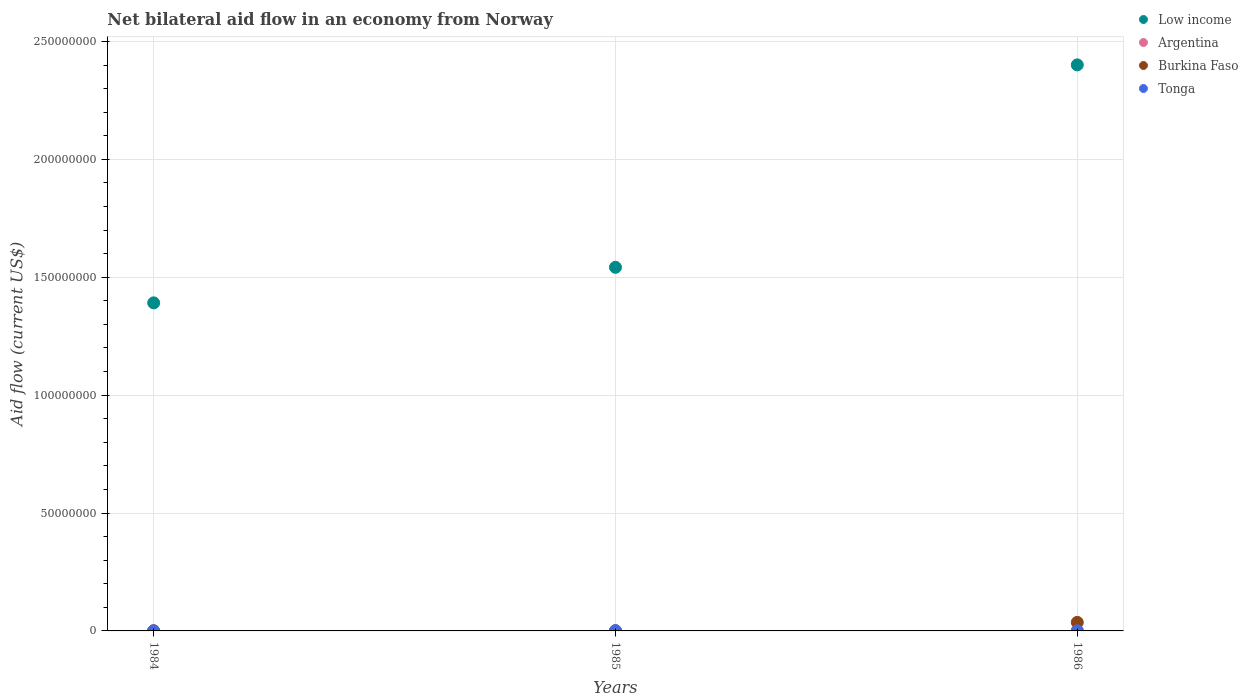What is the net bilateral aid flow in Burkina Faso in 1985?
Offer a terse response. 2.00e+04. Across all years, what is the maximum net bilateral aid flow in Argentina?
Make the answer very short. 1.70e+05. In which year was the net bilateral aid flow in Tonga maximum?
Your answer should be compact. 1985. What is the total net bilateral aid flow in Low income in the graph?
Make the answer very short. 5.33e+08. What is the difference between the net bilateral aid flow in Burkina Faso in 1984 and that in 1986?
Offer a very short reply. -3.59e+06. What is the difference between the net bilateral aid flow in Burkina Faso in 1984 and the net bilateral aid flow in Argentina in 1986?
Offer a terse response. -1.30e+05. What is the average net bilateral aid flow in Burkina Faso per year?
Make the answer very short. 1.23e+06. In the year 1984, what is the difference between the net bilateral aid flow in Low income and net bilateral aid flow in Tonga?
Provide a succinct answer. 1.39e+08. In how many years, is the net bilateral aid flow in Low income greater than 20000000 US$?
Make the answer very short. 3. Is the net bilateral aid flow in Low income in 1985 less than that in 1986?
Provide a succinct answer. Yes. Is the difference between the net bilateral aid flow in Low income in 1984 and 1985 greater than the difference between the net bilateral aid flow in Tonga in 1984 and 1985?
Your response must be concise. No. What is the difference between the highest and the second highest net bilateral aid flow in Burkina Faso?
Offer a terse response. 3.59e+06. What is the difference between the highest and the lowest net bilateral aid flow in Low income?
Give a very brief answer. 1.01e+08. In how many years, is the net bilateral aid flow in Argentina greater than the average net bilateral aid flow in Argentina taken over all years?
Keep it short and to the point. 1. Is the sum of the net bilateral aid flow in Low income in 1984 and 1986 greater than the maximum net bilateral aid flow in Tonga across all years?
Make the answer very short. Yes. Is it the case that in every year, the sum of the net bilateral aid flow in Low income and net bilateral aid flow in Tonga  is greater than the net bilateral aid flow in Burkina Faso?
Offer a very short reply. Yes. Does the net bilateral aid flow in Tonga monotonically increase over the years?
Offer a terse response. No. Is the net bilateral aid flow in Low income strictly greater than the net bilateral aid flow in Tonga over the years?
Give a very brief answer. Yes. How many dotlines are there?
Provide a short and direct response. 4. How many years are there in the graph?
Keep it short and to the point. 3. What is the difference between two consecutive major ticks on the Y-axis?
Provide a short and direct response. 5.00e+07. Are the values on the major ticks of Y-axis written in scientific E-notation?
Give a very brief answer. No. Does the graph contain grids?
Keep it short and to the point. Yes. Where does the legend appear in the graph?
Provide a succinct answer. Top right. How many legend labels are there?
Make the answer very short. 4. What is the title of the graph?
Offer a terse response. Net bilateral aid flow in an economy from Norway. Does "Middle East & North Africa (developing only)" appear as one of the legend labels in the graph?
Your answer should be compact. No. What is the label or title of the X-axis?
Offer a terse response. Years. What is the label or title of the Y-axis?
Offer a terse response. Aid flow (current US$). What is the Aid flow (current US$) in Low income in 1984?
Your answer should be very brief. 1.39e+08. What is the Aid flow (current US$) of Argentina in 1984?
Provide a short and direct response. 2.00e+04. What is the Aid flow (current US$) in Burkina Faso in 1984?
Give a very brief answer. 4.00e+04. What is the Aid flow (current US$) in Tonga in 1984?
Your answer should be very brief. 2.00e+04. What is the Aid flow (current US$) in Low income in 1985?
Provide a short and direct response. 1.54e+08. What is the Aid flow (current US$) in Burkina Faso in 1985?
Keep it short and to the point. 2.00e+04. What is the Aid flow (current US$) in Low income in 1986?
Offer a terse response. 2.40e+08. What is the Aid flow (current US$) in Argentina in 1986?
Provide a succinct answer. 1.70e+05. What is the Aid flow (current US$) of Burkina Faso in 1986?
Offer a terse response. 3.63e+06. Across all years, what is the maximum Aid flow (current US$) of Low income?
Make the answer very short. 2.40e+08. Across all years, what is the maximum Aid flow (current US$) of Burkina Faso?
Ensure brevity in your answer.  3.63e+06. Across all years, what is the maximum Aid flow (current US$) of Tonga?
Ensure brevity in your answer.  1.00e+05. Across all years, what is the minimum Aid flow (current US$) of Low income?
Keep it short and to the point. 1.39e+08. Across all years, what is the minimum Aid flow (current US$) of Burkina Faso?
Make the answer very short. 2.00e+04. What is the total Aid flow (current US$) of Low income in the graph?
Your response must be concise. 5.33e+08. What is the total Aid flow (current US$) in Argentina in the graph?
Your answer should be very brief. 2.40e+05. What is the total Aid flow (current US$) of Burkina Faso in the graph?
Your answer should be compact. 3.69e+06. What is the total Aid flow (current US$) in Tonga in the graph?
Make the answer very short. 1.70e+05. What is the difference between the Aid flow (current US$) in Low income in 1984 and that in 1985?
Give a very brief answer. -1.51e+07. What is the difference between the Aid flow (current US$) in Low income in 1984 and that in 1986?
Make the answer very short. -1.01e+08. What is the difference between the Aid flow (current US$) of Burkina Faso in 1984 and that in 1986?
Make the answer very short. -3.59e+06. What is the difference between the Aid flow (current US$) of Low income in 1985 and that in 1986?
Your answer should be very brief. -8.59e+07. What is the difference between the Aid flow (current US$) in Argentina in 1985 and that in 1986?
Your answer should be very brief. -1.20e+05. What is the difference between the Aid flow (current US$) in Burkina Faso in 1985 and that in 1986?
Give a very brief answer. -3.61e+06. What is the difference between the Aid flow (current US$) in Low income in 1984 and the Aid flow (current US$) in Argentina in 1985?
Provide a succinct answer. 1.39e+08. What is the difference between the Aid flow (current US$) in Low income in 1984 and the Aid flow (current US$) in Burkina Faso in 1985?
Offer a terse response. 1.39e+08. What is the difference between the Aid flow (current US$) of Low income in 1984 and the Aid flow (current US$) of Tonga in 1985?
Provide a short and direct response. 1.39e+08. What is the difference between the Aid flow (current US$) of Argentina in 1984 and the Aid flow (current US$) of Burkina Faso in 1985?
Your answer should be very brief. 0. What is the difference between the Aid flow (current US$) in Argentina in 1984 and the Aid flow (current US$) in Tonga in 1985?
Keep it short and to the point. -8.00e+04. What is the difference between the Aid flow (current US$) in Low income in 1984 and the Aid flow (current US$) in Argentina in 1986?
Offer a terse response. 1.39e+08. What is the difference between the Aid flow (current US$) of Low income in 1984 and the Aid flow (current US$) of Burkina Faso in 1986?
Keep it short and to the point. 1.36e+08. What is the difference between the Aid flow (current US$) in Low income in 1984 and the Aid flow (current US$) in Tonga in 1986?
Provide a short and direct response. 1.39e+08. What is the difference between the Aid flow (current US$) of Argentina in 1984 and the Aid flow (current US$) of Burkina Faso in 1986?
Keep it short and to the point. -3.61e+06. What is the difference between the Aid flow (current US$) in Low income in 1985 and the Aid flow (current US$) in Argentina in 1986?
Give a very brief answer. 1.54e+08. What is the difference between the Aid flow (current US$) in Low income in 1985 and the Aid flow (current US$) in Burkina Faso in 1986?
Offer a terse response. 1.51e+08. What is the difference between the Aid flow (current US$) in Low income in 1985 and the Aid flow (current US$) in Tonga in 1986?
Offer a very short reply. 1.54e+08. What is the difference between the Aid flow (current US$) of Argentina in 1985 and the Aid flow (current US$) of Burkina Faso in 1986?
Provide a short and direct response. -3.58e+06. What is the difference between the Aid flow (current US$) in Argentina in 1985 and the Aid flow (current US$) in Tonga in 1986?
Make the answer very short. 0. What is the difference between the Aid flow (current US$) of Burkina Faso in 1985 and the Aid flow (current US$) of Tonga in 1986?
Offer a very short reply. -3.00e+04. What is the average Aid flow (current US$) in Low income per year?
Provide a succinct answer. 1.78e+08. What is the average Aid flow (current US$) of Argentina per year?
Provide a short and direct response. 8.00e+04. What is the average Aid flow (current US$) of Burkina Faso per year?
Provide a succinct answer. 1.23e+06. What is the average Aid flow (current US$) in Tonga per year?
Make the answer very short. 5.67e+04. In the year 1984, what is the difference between the Aid flow (current US$) of Low income and Aid flow (current US$) of Argentina?
Keep it short and to the point. 1.39e+08. In the year 1984, what is the difference between the Aid flow (current US$) of Low income and Aid flow (current US$) of Burkina Faso?
Keep it short and to the point. 1.39e+08. In the year 1984, what is the difference between the Aid flow (current US$) of Low income and Aid flow (current US$) of Tonga?
Provide a succinct answer. 1.39e+08. In the year 1984, what is the difference between the Aid flow (current US$) in Argentina and Aid flow (current US$) in Burkina Faso?
Your answer should be very brief. -2.00e+04. In the year 1984, what is the difference between the Aid flow (current US$) of Argentina and Aid flow (current US$) of Tonga?
Your answer should be compact. 0. In the year 1985, what is the difference between the Aid flow (current US$) in Low income and Aid flow (current US$) in Argentina?
Offer a very short reply. 1.54e+08. In the year 1985, what is the difference between the Aid flow (current US$) of Low income and Aid flow (current US$) of Burkina Faso?
Make the answer very short. 1.54e+08. In the year 1985, what is the difference between the Aid flow (current US$) of Low income and Aid flow (current US$) of Tonga?
Your answer should be very brief. 1.54e+08. In the year 1985, what is the difference between the Aid flow (current US$) of Argentina and Aid flow (current US$) of Burkina Faso?
Provide a succinct answer. 3.00e+04. In the year 1986, what is the difference between the Aid flow (current US$) in Low income and Aid flow (current US$) in Argentina?
Provide a succinct answer. 2.40e+08. In the year 1986, what is the difference between the Aid flow (current US$) in Low income and Aid flow (current US$) in Burkina Faso?
Offer a very short reply. 2.36e+08. In the year 1986, what is the difference between the Aid flow (current US$) in Low income and Aid flow (current US$) in Tonga?
Keep it short and to the point. 2.40e+08. In the year 1986, what is the difference between the Aid flow (current US$) in Argentina and Aid flow (current US$) in Burkina Faso?
Your answer should be very brief. -3.46e+06. In the year 1986, what is the difference between the Aid flow (current US$) of Burkina Faso and Aid flow (current US$) of Tonga?
Make the answer very short. 3.58e+06. What is the ratio of the Aid flow (current US$) in Low income in 1984 to that in 1985?
Ensure brevity in your answer.  0.9. What is the ratio of the Aid flow (current US$) in Argentina in 1984 to that in 1985?
Provide a short and direct response. 0.4. What is the ratio of the Aid flow (current US$) of Low income in 1984 to that in 1986?
Offer a terse response. 0.58. What is the ratio of the Aid flow (current US$) of Argentina in 1984 to that in 1986?
Give a very brief answer. 0.12. What is the ratio of the Aid flow (current US$) of Burkina Faso in 1984 to that in 1986?
Provide a short and direct response. 0.01. What is the ratio of the Aid flow (current US$) of Tonga in 1984 to that in 1986?
Provide a short and direct response. 0.4. What is the ratio of the Aid flow (current US$) of Low income in 1985 to that in 1986?
Make the answer very short. 0.64. What is the ratio of the Aid flow (current US$) in Argentina in 1985 to that in 1986?
Provide a short and direct response. 0.29. What is the ratio of the Aid flow (current US$) of Burkina Faso in 1985 to that in 1986?
Keep it short and to the point. 0.01. What is the difference between the highest and the second highest Aid flow (current US$) of Low income?
Offer a very short reply. 8.59e+07. What is the difference between the highest and the second highest Aid flow (current US$) of Argentina?
Ensure brevity in your answer.  1.20e+05. What is the difference between the highest and the second highest Aid flow (current US$) in Burkina Faso?
Your answer should be compact. 3.59e+06. What is the difference between the highest and the second highest Aid flow (current US$) in Tonga?
Offer a terse response. 5.00e+04. What is the difference between the highest and the lowest Aid flow (current US$) of Low income?
Offer a terse response. 1.01e+08. What is the difference between the highest and the lowest Aid flow (current US$) in Burkina Faso?
Your answer should be compact. 3.61e+06. 